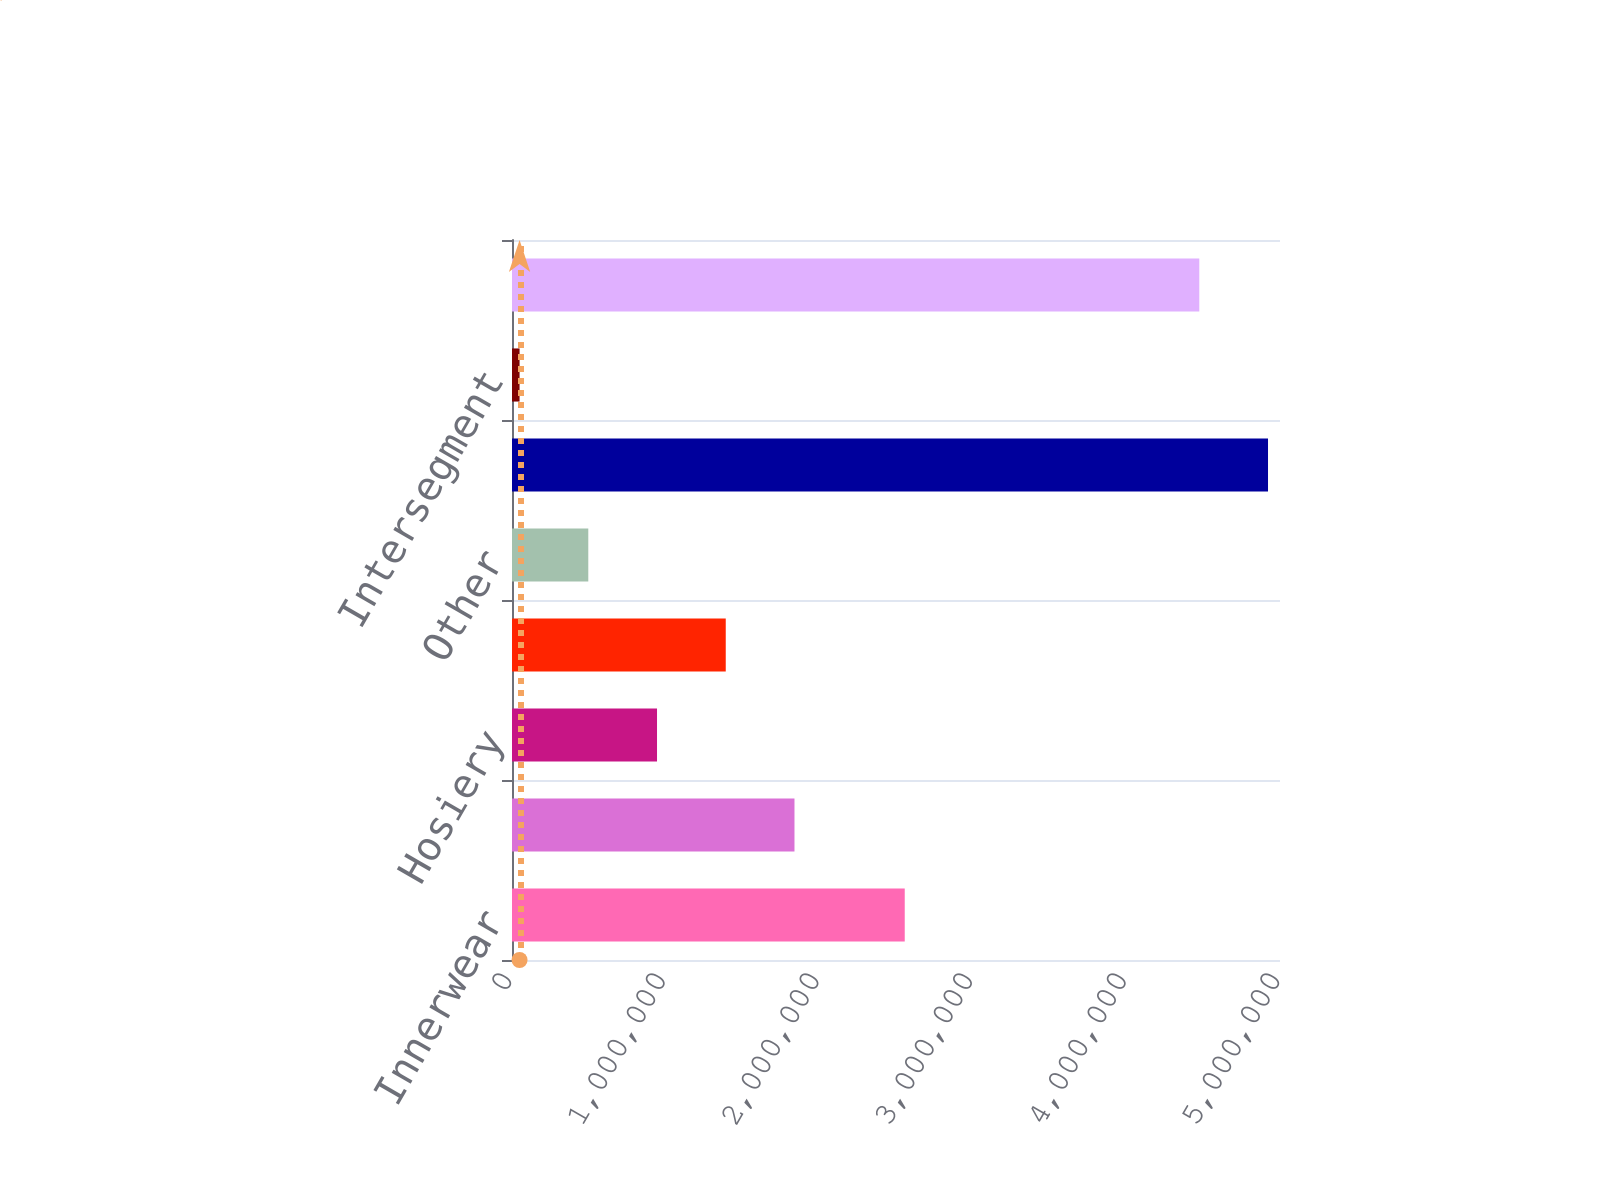Convert chart. <chart><loc_0><loc_0><loc_500><loc_500><bar_chart><fcel>Innerwear<fcel>Outerwear<fcel>Hosiery<fcel>International<fcel>Other<fcel>Total segment net sales<fcel>Intersegment<fcel>Total net sales<nl><fcel>2.55691e+06<fcel>1.83904e+06<fcel>944137<fcel>1.39159e+06<fcel>496684<fcel>4.92199e+06<fcel>49230<fcel>4.47454e+06<nl></chart> 